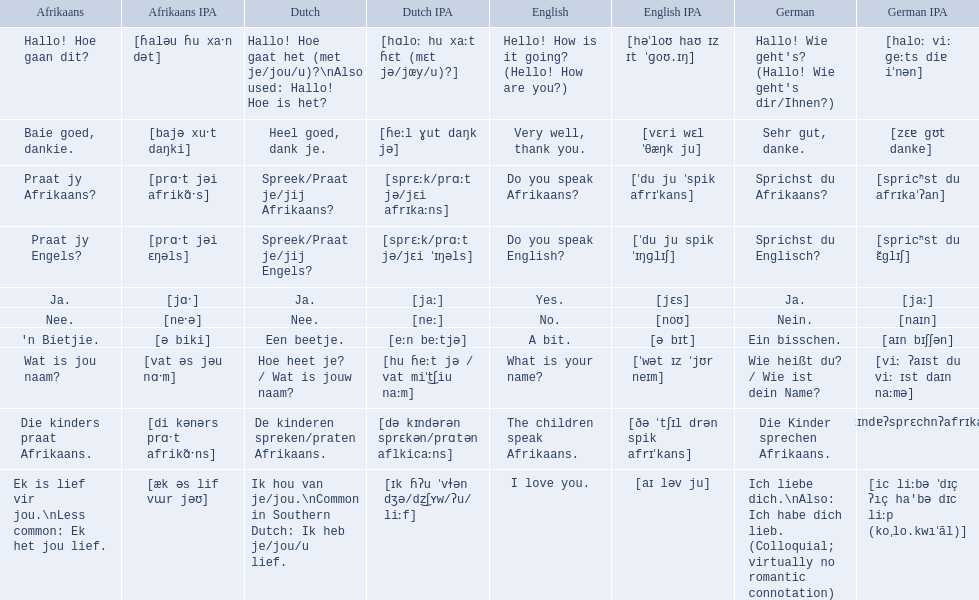What are the afrikaans phrases? Hallo! Hoe gaan dit?, Baie goed, dankie., Praat jy Afrikaans?, Praat jy Engels?, Ja., Nee., 'n Bietjie., Wat is jou naam?, Die kinders praat Afrikaans., Ek is lief vir jou.\nLess common: Ek het jou lief. For die kinders praat afrikaans, what are the translations? De kinderen spreken/praten Afrikaans., The children speak Afrikaans., Die Kinder sprechen Afrikaans. Which one is the german translation? Die Kinder sprechen Afrikaans. 